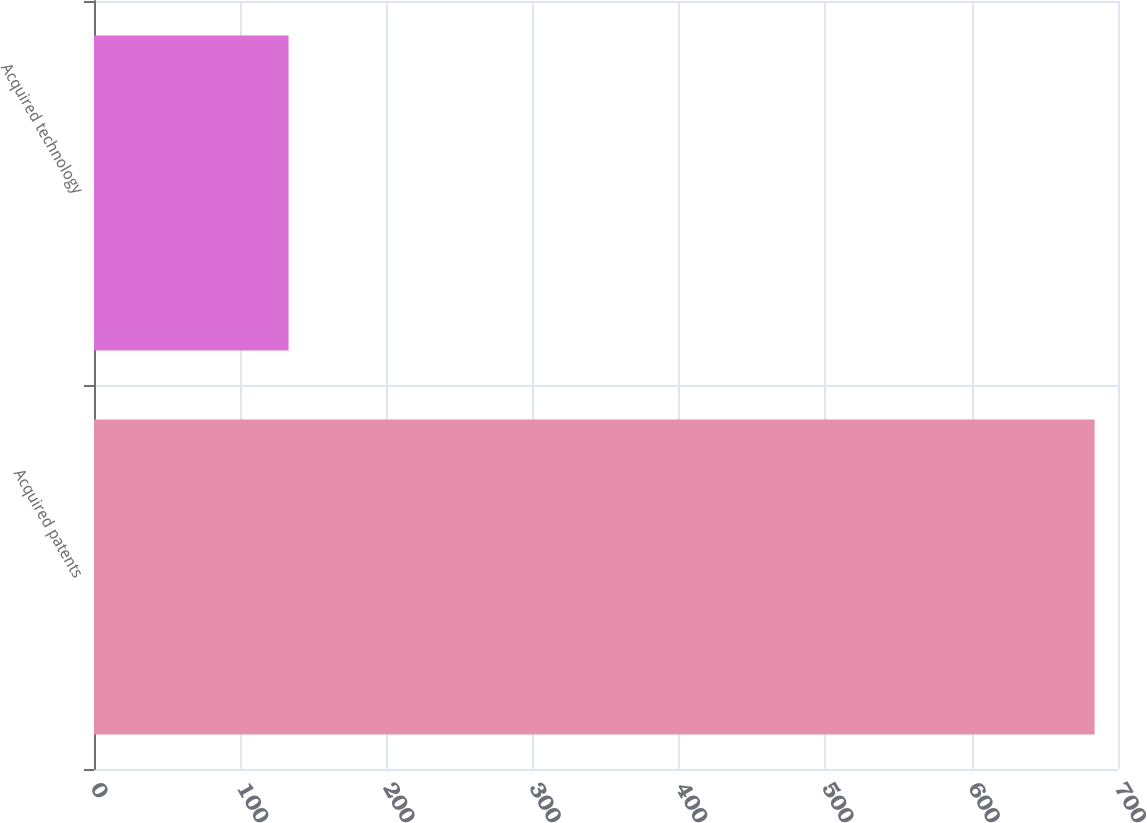Convert chart to OTSL. <chart><loc_0><loc_0><loc_500><loc_500><bar_chart><fcel>Acquired patents<fcel>Acquired technology<nl><fcel>684<fcel>133<nl></chart> 